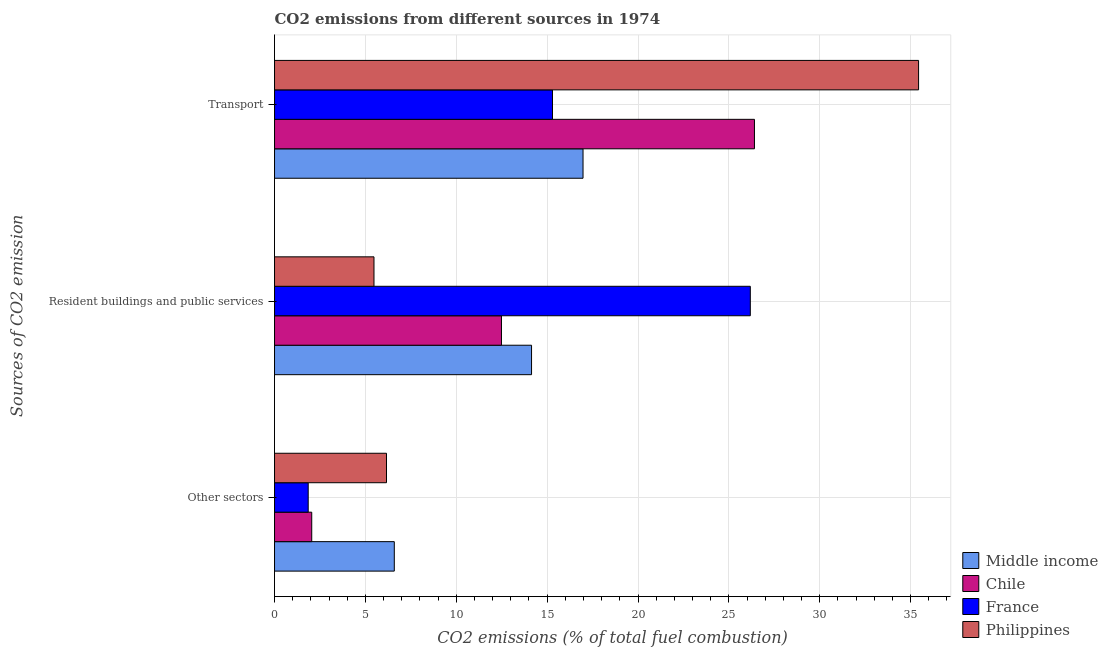How many groups of bars are there?
Provide a short and direct response. 3. Are the number of bars per tick equal to the number of legend labels?
Your response must be concise. Yes. How many bars are there on the 2nd tick from the top?
Offer a very short reply. 4. How many bars are there on the 3rd tick from the bottom?
Provide a short and direct response. 4. What is the label of the 1st group of bars from the top?
Provide a succinct answer. Transport. What is the percentage of co2 emissions from other sectors in Philippines?
Provide a succinct answer. 6.16. Across all countries, what is the maximum percentage of co2 emissions from resident buildings and public services?
Provide a short and direct response. 26.18. Across all countries, what is the minimum percentage of co2 emissions from transport?
Your answer should be compact. 15.29. In which country was the percentage of co2 emissions from resident buildings and public services minimum?
Ensure brevity in your answer.  Philippines. What is the total percentage of co2 emissions from transport in the graph?
Your answer should be very brief. 94.12. What is the difference between the percentage of co2 emissions from transport in Middle income and that in Philippines?
Give a very brief answer. -18.46. What is the difference between the percentage of co2 emissions from other sectors in Philippines and the percentage of co2 emissions from resident buildings and public services in Chile?
Provide a succinct answer. -6.33. What is the average percentage of co2 emissions from other sectors per country?
Provide a succinct answer. 4.16. What is the difference between the percentage of co2 emissions from other sectors and percentage of co2 emissions from transport in Middle income?
Provide a short and direct response. -10.39. In how many countries, is the percentage of co2 emissions from other sectors greater than 14 %?
Your answer should be very brief. 0. What is the ratio of the percentage of co2 emissions from other sectors in Chile to that in Middle income?
Provide a succinct answer. 0.31. Is the percentage of co2 emissions from resident buildings and public services in Chile less than that in France?
Keep it short and to the point. Yes. What is the difference between the highest and the second highest percentage of co2 emissions from resident buildings and public services?
Ensure brevity in your answer.  12.04. What is the difference between the highest and the lowest percentage of co2 emissions from other sectors?
Your answer should be very brief. 4.74. Is the sum of the percentage of co2 emissions from resident buildings and public services in Philippines and France greater than the maximum percentage of co2 emissions from other sectors across all countries?
Your answer should be compact. Yes. What does the 2nd bar from the top in Transport represents?
Offer a terse response. France. Is it the case that in every country, the sum of the percentage of co2 emissions from other sectors and percentage of co2 emissions from resident buildings and public services is greater than the percentage of co2 emissions from transport?
Your answer should be compact. No. Are all the bars in the graph horizontal?
Provide a short and direct response. Yes. How many countries are there in the graph?
Your answer should be compact. 4. Does the graph contain any zero values?
Your answer should be very brief. No. Does the graph contain grids?
Provide a succinct answer. Yes. What is the title of the graph?
Offer a very short reply. CO2 emissions from different sources in 1974. Does "Zambia" appear as one of the legend labels in the graph?
Your response must be concise. No. What is the label or title of the X-axis?
Offer a terse response. CO2 emissions (% of total fuel combustion). What is the label or title of the Y-axis?
Your answer should be compact. Sources of CO2 emission. What is the CO2 emissions (% of total fuel combustion) in Middle income in Other sectors?
Your answer should be compact. 6.59. What is the CO2 emissions (% of total fuel combustion) of Chile in Other sectors?
Offer a very short reply. 2.05. What is the CO2 emissions (% of total fuel combustion) in France in Other sectors?
Offer a very short reply. 1.85. What is the CO2 emissions (% of total fuel combustion) of Philippines in Other sectors?
Provide a succinct answer. 6.16. What is the CO2 emissions (% of total fuel combustion) in Middle income in Resident buildings and public services?
Give a very brief answer. 14.14. What is the CO2 emissions (% of total fuel combustion) of Chile in Resident buildings and public services?
Ensure brevity in your answer.  12.49. What is the CO2 emissions (% of total fuel combustion) in France in Resident buildings and public services?
Your answer should be compact. 26.18. What is the CO2 emissions (% of total fuel combustion) in Philippines in Resident buildings and public services?
Your answer should be very brief. 5.47. What is the CO2 emissions (% of total fuel combustion) of Middle income in Transport?
Provide a short and direct response. 16.97. What is the CO2 emissions (% of total fuel combustion) of Chile in Transport?
Your response must be concise. 26.41. What is the CO2 emissions (% of total fuel combustion) in France in Transport?
Offer a very short reply. 15.29. What is the CO2 emissions (% of total fuel combustion) of Philippines in Transport?
Your response must be concise. 35.44. Across all Sources of CO2 emission, what is the maximum CO2 emissions (% of total fuel combustion) in Middle income?
Your answer should be compact. 16.97. Across all Sources of CO2 emission, what is the maximum CO2 emissions (% of total fuel combustion) in Chile?
Give a very brief answer. 26.41. Across all Sources of CO2 emission, what is the maximum CO2 emissions (% of total fuel combustion) of France?
Your answer should be compact. 26.18. Across all Sources of CO2 emission, what is the maximum CO2 emissions (% of total fuel combustion) of Philippines?
Make the answer very short. 35.44. Across all Sources of CO2 emission, what is the minimum CO2 emissions (% of total fuel combustion) in Middle income?
Give a very brief answer. 6.59. Across all Sources of CO2 emission, what is the minimum CO2 emissions (% of total fuel combustion) in Chile?
Your response must be concise. 2.05. Across all Sources of CO2 emission, what is the minimum CO2 emissions (% of total fuel combustion) of France?
Keep it short and to the point. 1.85. Across all Sources of CO2 emission, what is the minimum CO2 emissions (% of total fuel combustion) in Philippines?
Your answer should be compact. 5.47. What is the total CO2 emissions (% of total fuel combustion) of Middle income in the graph?
Your answer should be compact. 37.71. What is the total CO2 emissions (% of total fuel combustion) in Chile in the graph?
Offer a very short reply. 40.94. What is the total CO2 emissions (% of total fuel combustion) in France in the graph?
Give a very brief answer. 43.33. What is the total CO2 emissions (% of total fuel combustion) of Philippines in the graph?
Your response must be concise. 47.07. What is the difference between the CO2 emissions (% of total fuel combustion) in Middle income in Other sectors and that in Resident buildings and public services?
Offer a very short reply. -7.55. What is the difference between the CO2 emissions (% of total fuel combustion) of Chile in Other sectors and that in Resident buildings and public services?
Provide a short and direct response. -10.44. What is the difference between the CO2 emissions (% of total fuel combustion) in France in Other sectors and that in Resident buildings and public services?
Give a very brief answer. -24.33. What is the difference between the CO2 emissions (% of total fuel combustion) of Philippines in Other sectors and that in Resident buildings and public services?
Your answer should be compact. 0.69. What is the difference between the CO2 emissions (% of total fuel combustion) in Middle income in Other sectors and that in Transport?
Your answer should be compact. -10.38. What is the difference between the CO2 emissions (% of total fuel combustion) in Chile in Other sectors and that in Transport?
Your answer should be compact. -24.36. What is the difference between the CO2 emissions (% of total fuel combustion) of France in Other sectors and that in Transport?
Provide a succinct answer. -13.44. What is the difference between the CO2 emissions (% of total fuel combustion) in Philippines in Other sectors and that in Transport?
Your answer should be compact. -29.28. What is the difference between the CO2 emissions (% of total fuel combustion) of Middle income in Resident buildings and public services and that in Transport?
Your answer should be compact. -2.83. What is the difference between the CO2 emissions (% of total fuel combustion) in Chile in Resident buildings and public services and that in Transport?
Provide a short and direct response. -13.92. What is the difference between the CO2 emissions (% of total fuel combustion) of France in Resident buildings and public services and that in Transport?
Your answer should be very brief. 10.88. What is the difference between the CO2 emissions (% of total fuel combustion) of Philippines in Resident buildings and public services and that in Transport?
Your answer should be compact. -29.97. What is the difference between the CO2 emissions (% of total fuel combustion) of Middle income in Other sectors and the CO2 emissions (% of total fuel combustion) of Chile in Resident buildings and public services?
Provide a succinct answer. -5.9. What is the difference between the CO2 emissions (% of total fuel combustion) of Middle income in Other sectors and the CO2 emissions (% of total fuel combustion) of France in Resident buildings and public services?
Provide a succinct answer. -19.59. What is the difference between the CO2 emissions (% of total fuel combustion) of Middle income in Other sectors and the CO2 emissions (% of total fuel combustion) of Philippines in Resident buildings and public services?
Keep it short and to the point. 1.12. What is the difference between the CO2 emissions (% of total fuel combustion) of Chile in Other sectors and the CO2 emissions (% of total fuel combustion) of France in Resident buildings and public services?
Offer a very short reply. -24.13. What is the difference between the CO2 emissions (% of total fuel combustion) in Chile in Other sectors and the CO2 emissions (% of total fuel combustion) in Philippines in Resident buildings and public services?
Your answer should be very brief. -3.43. What is the difference between the CO2 emissions (% of total fuel combustion) of France in Other sectors and the CO2 emissions (% of total fuel combustion) of Philippines in Resident buildings and public services?
Give a very brief answer. -3.62. What is the difference between the CO2 emissions (% of total fuel combustion) of Middle income in Other sectors and the CO2 emissions (% of total fuel combustion) of Chile in Transport?
Your answer should be very brief. -19.82. What is the difference between the CO2 emissions (% of total fuel combustion) in Middle income in Other sectors and the CO2 emissions (% of total fuel combustion) in France in Transport?
Give a very brief answer. -8.71. What is the difference between the CO2 emissions (% of total fuel combustion) of Middle income in Other sectors and the CO2 emissions (% of total fuel combustion) of Philippines in Transport?
Keep it short and to the point. -28.85. What is the difference between the CO2 emissions (% of total fuel combustion) of Chile in Other sectors and the CO2 emissions (% of total fuel combustion) of France in Transport?
Your answer should be very brief. -13.25. What is the difference between the CO2 emissions (% of total fuel combustion) of Chile in Other sectors and the CO2 emissions (% of total fuel combustion) of Philippines in Transport?
Make the answer very short. -33.39. What is the difference between the CO2 emissions (% of total fuel combustion) in France in Other sectors and the CO2 emissions (% of total fuel combustion) in Philippines in Transport?
Your answer should be compact. -33.59. What is the difference between the CO2 emissions (% of total fuel combustion) in Middle income in Resident buildings and public services and the CO2 emissions (% of total fuel combustion) in Chile in Transport?
Make the answer very short. -12.26. What is the difference between the CO2 emissions (% of total fuel combustion) of Middle income in Resident buildings and public services and the CO2 emissions (% of total fuel combustion) of France in Transport?
Your response must be concise. -1.15. What is the difference between the CO2 emissions (% of total fuel combustion) in Middle income in Resident buildings and public services and the CO2 emissions (% of total fuel combustion) in Philippines in Transport?
Your answer should be very brief. -21.3. What is the difference between the CO2 emissions (% of total fuel combustion) in Chile in Resident buildings and public services and the CO2 emissions (% of total fuel combustion) in France in Transport?
Keep it short and to the point. -2.81. What is the difference between the CO2 emissions (% of total fuel combustion) in Chile in Resident buildings and public services and the CO2 emissions (% of total fuel combustion) in Philippines in Transport?
Your answer should be compact. -22.95. What is the difference between the CO2 emissions (% of total fuel combustion) of France in Resident buildings and public services and the CO2 emissions (% of total fuel combustion) of Philippines in Transport?
Offer a terse response. -9.26. What is the average CO2 emissions (% of total fuel combustion) in Middle income per Sources of CO2 emission?
Ensure brevity in your answer.  12.57. What is the average CO2 emissions (% of total fuel combustion) of Chile per Sources of CO2 emission?
Ensure brevity in your answer.  13.65. What is the average CO2 emissions (% of total fuel combustion) of France per Sources of CO2 emission?
Provide a succinct answer. 14.44. What is the average CO2 emissions (% of total fuel combustion) in Philippines per Sources of CO2 emission?
Keep it short and to the point. 15.69. What is the difference between the CO2 emissions (% of total fuel combustion) of Middle income and CO2 emissions (% of total fuel combustion) of Chile in Other sectors?
Offer a terse response. 4.54. What is the difference between the CO2 emissions (% of total fuel combustion) of Middle income and CO2 emissions (% of total fuel combustion) of France in Other sectors?
Your answer should be very brief. 4.74. What is the difference between the CO2 emissions (% of total fuel combustion) in Middle income and CO2 emissions (% of total fuel combustion) in Philippines in Other sectors?
Make the answer very short. 0.43. What is the difference between the CO2 emissions (% of total fuel combustion) of Chile and CO2 emissions (% of total fuel combustion) of France in Other sectors?
Ensure brevity in your answer.  0.19. What is the difference between the CO2 emissions (% of total fuel combustion) of Chile and CO2 emissions (% of total fuel combustion) of Philippines in Other sectors?
Offer a very short reply. -4.11. What is the difference between the CO2 emissions (% of total fuel combustion) in France and CO2 emissions (% of total fuel combustion) in Philippines in Other sectors?
Give a very brief answer. -4.31. What is the difference between the CO2 emissions (% of total fuel combustion) of Middle income and CO2 emissions (% of total fuel combustion) of Chile in Resident buildings and public services?
Ensure brevity in your answer.  1.66. What is the difference between the CO2 emissions (% of total fuel combustion) in Middle income and CO2 emissions (% of total fuel combustion) in France in Resident buildings and public services?
Offer a terse response. -12.04. What is the difference between the CO2 emissions (% of total fuel combustion) of Middle income and CO2 emissions (% of total fuel combustion) of Philippines in Resident buildings and public services?
Your answer should be very brief. 8.67. What is the difference between the CO2 emissions (% of total fuel combustion) of Chile and CO2 emissions (% of total fuel combustion) of France in Resident buildings and public services?
Your answer should be very brief. -13.69. What is the difference between the CO2 emissions (% of total fuel combustion) of Chile and CO2 emissions (% of total fuel combustion) of Philippines in Resident buildings and public services?
Make the answer very short. 7.01. What is the difference between the CO2 emissions (% of total fuel combustion) in France and CO2 emissions (% of total fuel combustion) in Philippines in Resident buildings and public services?
Make the answer very short. 20.71. What is the difference between the CO2 emissions (% of total fuel combustion) in Middle income and CO2 emissions (% of total fuel combustion) in Chile in Transport?
Provide a succinct answer. -9.43. What is the difference between the CO2 emissions (% of total fuel combustion) in Middle income and CO2 emissions (% of total fuel combustion) in France in Transport?
Keep it short and to the point. 1.68. What is the difference between the CO2 emissions (% of total fuel combustion) in Middle income and CO2 emissions (% of total fuel combustion) in Philippines in Transport?
Provide a succinct answer. -18.46. What is the difference between the CO2 emissions (% of total fuel combustion) in Chile and CO2 emissions (% of total fuel combustion) in France in Transport?
Offer a very short reply. 11.11. What is the difference between the CO2 emissions (% of total fuel combustion) of Chile and CO2 emissions (% of total fuel combustion) of Philippines in Transport?
Your response must be concise. -9.03. What is the difference between the CO2 emissions (% of total fuel combustion) in France and CO2 emissions (% of total fuel combustion) in Philippines in Transport?
Make the answer very short. -20.14. What is the ratio of the CO2 emissions (% of total fuel combustion) in Middle income in Other sectors to that in Resident buildings and public services?
Provide a short and direct response. 0.47. What is the ratio of the CO2 emissions (% of total fuel combustion) of Chile in Other sectors to that in Resident buildings and public services?
Keep it short and to the point. 0.16. What is the ratio of the CO2 emissions (% of total fuel combustion) in France in Other sectors to that in Resident buildings and public services?
Provide a succinct answer. 0.07. What is the ratio of the CO2 emissions (% of total fuel combustion) in Philippines in Other sectors to that in Resident buildings and public services?
Your answer should be very brief. 1.13. What is the ratio of the CO2 emissions (% of total fuel combustion) of Middle income in Other sectors to that in Transport?
Your answer should be compact. 0.39. What is the ratio of the CO2 emissions (% of total fuel combustion) of Chile in Other sectors to that in Transport?
Ensure brevity in your answer.  0.08. What is the ratio of the CO2 emissions (% of total fuel combustion) in France in Other sectors to that in Transport?
Offer a terse response. 0.12. What is the ratio of the CO2 emissions (% of total fuel combustion) of Philippines in Other sectors to that in Transport?
Offer a terse response. 0.17. What is the ratio of the CO2 emissions (% of total fuel combustion) of Middle income in Resident buildings and public services to that in Transport?
Provide a succinct answer. 0.83. What is the ratio of the CO2 emissions (% of total fuel combustion) of Chile in Resident buildings and public services to that in Transport?
Give a very brief answer. 0.47. What is the ratio of the CO2 emissions (% of total fuel combustion) in France in Resident buildings and public services to that in Transport?
Make the answer very short. 1.71. What is the ratio of the CO2 emissions (% of total fuel combustion) in Philippines in Resident buildings and public services to that in Transport?
Provide a short and direct response. 0.15. What is the difference between the highest and the second highest CO2 emissions (% of total fuel combustion) in Middle income?
Make the answer very short. 2.83. What is the difference between the highest and the second highest CO2 emissions (% of total fuel combustion) in Chile?
Offer a terse response. 13.92. What is the difference between the highest and the second highest CO2 emissions (% of total fuel combustion) in France?
Offer a very short reply. 10.88. What is the difference between the highest and the second highest CO2 emissions (% of total fuel combustion) of Philippines?
Offer a terse response. 29.28. What is the difference between the highest and the lowest CO2 emissions (% of total fuel combustion) of Middle income?
Ensure brevity in your answer.  10.38. What is the difference between the highest and the lowest CO2 emissions (% of total fuel combustion) of Chile?
Offer a very short reply. 24.36. What is the difference between the highest and the lowest CO2 emissions (% of total fuel combustion) of France?
Ensure brevity in your answer.  24.33. What is the difference between the highest and the lowest CO2 emissions (% of total fuel combustion) of Philippines?
Make the answer very short. 29.97. 